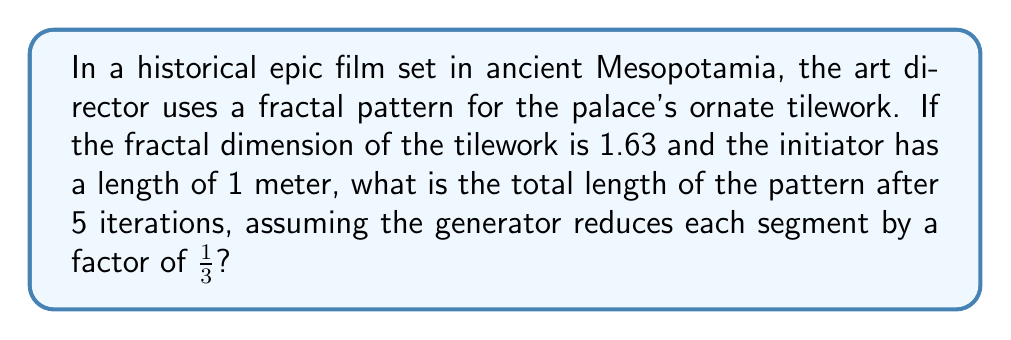Can you solve this math problem? To solve this problem, we'll use concepts from fractal geometry and the properties of self-similar sets. Let's break it down step-by-step:

1) The fractal dimension (D) is given as 1.63.

2) For a self-similar fractal, the dimension D is related to the number of copies (N) and the scaling factor (r) by the equation:

   $$D = \frac{\log N}{\log(1/r)}$$

3) We know r = 1/3, so let's solve for N:

   $$1.63 = \frac{\log N}{\log 3}$$
   $$1.63 \log 3 = \log N$$
   $$N = 3^{1.63} \approx 4.0856$$

4) This means each segment is replaced by approximately 4.0856 segments in each iteration.

5) The length of each new segment after n iterations is $(1/3)^n$ meters.

6) The total number of segments after n iterations is $N^n$.

7) Therefore, the total length after n iterations is:

   $$L_n = (1/3)^n \cdot N^n = (N/3)^n$$

8) For 5 iterations:

   $$L_5 = (4.0856/3)^5 \approx 2.8934$$

Thus, the total length after 5 iterations is approximately 2.8934 meters.
Answer: 2.8934 meters 